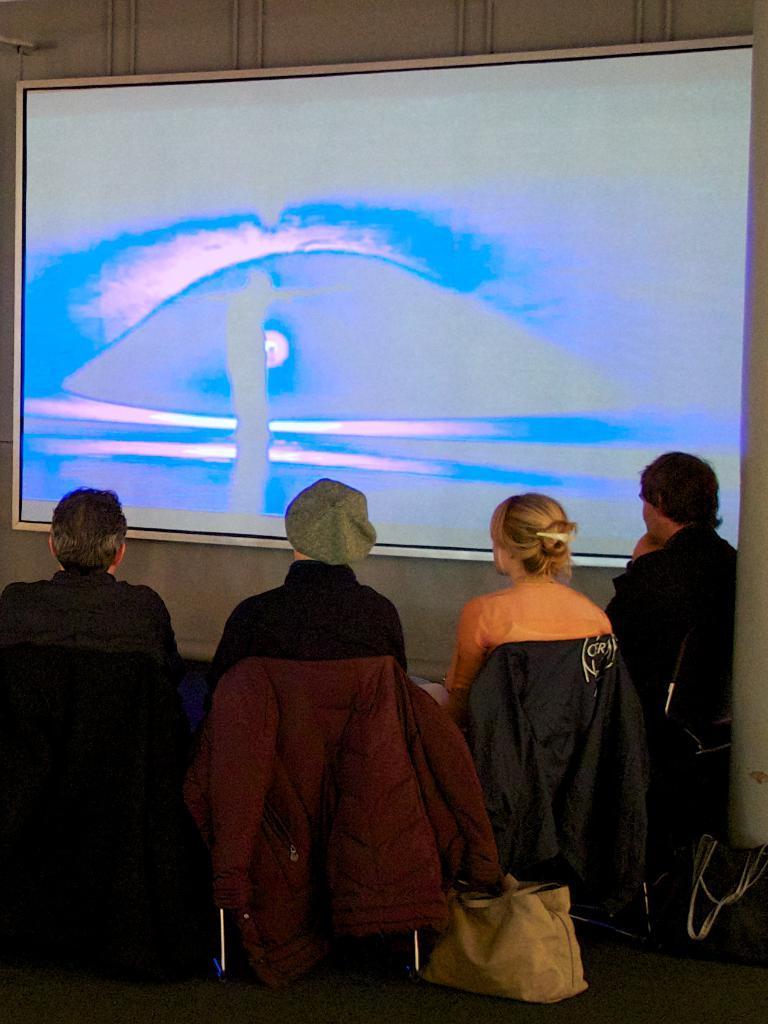Could you give a brief overview of what you see in this image? In this picture we can see group of people, behind them we can find few bags on the table, in front of them we can see a screen and few pipes. 